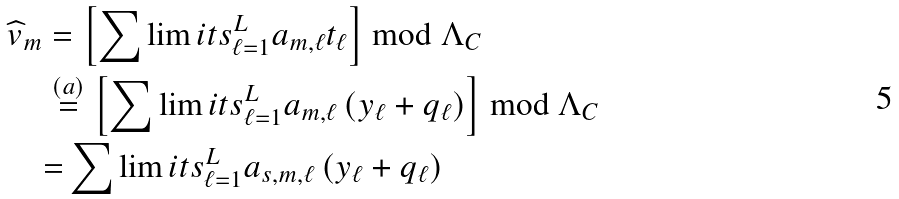<formula> <loc_0><loc_0><loc_500><loc_500>\widehat { v } _ { m } & = \left [ \sum \lim i t s _ { \ell = 1 } ^ { L } { a } _ { m , \ell } t _ { \ell } \right ] \bmod { \Lambda _ { C } } \\ & \stackrel { ( a ) } { = } \left [ \sum \lim i t s _ { \ell = 1 } ^ { L } { a } _ { m , \ell } \left ( { y } _ { \ell } + q _ { \ell } \right ) \right ] \bmod { \Lambda _ { C } } \\ & { = } \sum \lim i t s _ { \ell = 1 } ^ { L } { a } _ { s , m , \ell } \left ( { y } _ { \ell } + q _ { \ell } \right )</formula> 